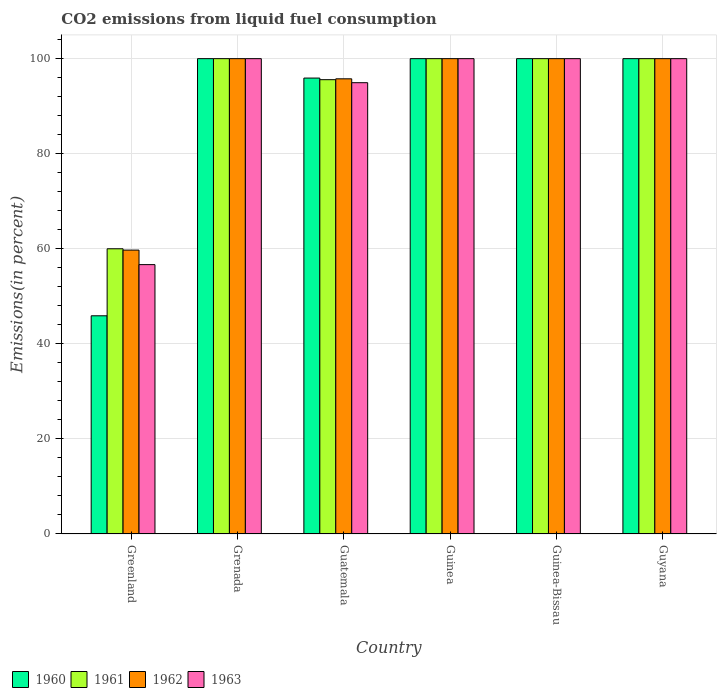Are the number of bars on each tick of the X-axis equal?
Ensure brevity in your answer.  Yes. What is the label of the 1st group of bars from the left?
Ensure brevity in your answer.  Greenland. In how many cases, is the number of bars for a given country not equal to the number of legend labels?
Offer a terse response. 0. What is the total CO2 emitted in 1961 in Greenland?
Offer a terse response. 60. Across all countries, what is the maximum total CO2 emitted in 1963?
Offer a very short reply. 100. Across all countries, what is the minimum total CO2 emitted in 1963?
Your answer should be very brief. 56.67. In which country was the total CO2 emitted in 1961 maximum?
Your answer should be very brief. Grenada. In which country was the total CO2 emitted in 1960 minimum?
Your answer should be very brief. Greenland. What is the total total CO2 emitted in 1962 in the graph?
Provide a succinct answer. 555.48. What is the difference between the total CO2 emitted in 1960 in Guinea-Bissau and that in Guyana?
Offer a very short reply. 0. What is the difference between the total CO2 emitted in 1961 in Guyana and the total CO2 emitted in 1963 in Greenland?
Provide a short and direct response. 43.33. What is the average total CO2 emitted in 1962 per country?
Give a very brief answer. 92.58. What is the difference between the total CO2 emitted of/in 1960 and total CO2 emitted of/in 1962 in Guatemala?
Ensure brevity in your answer.  0.16. In how many countries, is the total CO2 emitted in 1960 greater than 92 %?
Your answer should be compact. 5. What is the ratio of the total CO2 emitted in 1963 in Grenada to that in Guinea-Bissau?
Offer a terse response. 1. Is the difference between the total CO2 emitted in 1960 in Grenada and Guyana greater than the difference between the total CO2 emitted in 1962 in Grenada and Guyana?
Give a very brief answer. No. What is the difference between the highest and the lowest total CO2 emitted in 1961?
Give a very brief answer. 40. In how many countries, is the total CO2 emitted in 1961 greater than the average total CO2 emitted in 1961 taken over all countries?
Offer a terse response. 5. Is it the case that in every country, the sum of the total CO2 emitted in 1962 and total CO2 emitted in 1960 is greater than the sum of total CO2 emitted in 1961 and total CO2 emitted in 1963?
Offer a terse response. No. Is it the case that in every country, the sum of the total CO2 emitted in 1962 and total CO2 emitted in 1960 is greater than the total CO2 emitted in 1961?
Keep it short and to the point. Yes. How many bars are there?
Keep it short and to the point. 24. Are all the bars in the graph horizontal?
Provide a succinct answer. No. How many countries are there in the graph?
Make the answer very short. 6. Does the graph contain any zero values?
Keep it short and to the point. No. Does the graph contain grids?
Give a very brief answer. Yes. How many legend labels are there?
Keep it short and to the point. 4. What is the title of the graph?
Your response must be concise. CO2 emissions from liquid fuel consumption. Does "1989" appear as one of the legend labels in the graph?
Keep it short and to the point. No. What is the label or title of the X-axis?
Provide a short and direct response. Country. What is the label or title of the Y-axis?
Your response must be concise. Emissions(in percent). What is the Emissions(in percent) of 1960 in Greenland?
Provide a short and direct response. 45.9. What is the Emissions(in percent) of 1962 in Greenland?
Your answer should be very brief. 59.72. What is the Emissions(in percent) of 1963 in Greenland?
Offer a very short reply. 56.67. What is the Emissions(in percent) of 1960 in Grenada?
Your answer should be compact. 100. What is the Emissions(in percent) in 1963 in Grenada?
Keep it short and to the point. 100. What is the Emissions(in percent) of 1960 in Guatemala?
Give a very brief answer. 95.91. What is the Emissions(in percent) of 1961 in Guatemala?
Your answer should be very brief. 95.57. What is the Emissions(in percent) of 1962 in Guatemala?
Give a very brief answer. 95.76. What is the Emissions(in percent) of 1963 in Guatemala?
Make the answer very short. 94.94. What is the Emissions(in percent) of 1961 in Guinea?
Keep it short and to the point. 100. What is the Emissions(in percent) in 1962 in Guinea?
Your response must be concise. 100. What is the Emissions(in percent) in 1960 in Guinea-Bissau?
Ensure brevity in your answer.  100. What is the Emissions(in percent) in 1962 in Guinea-Bissau?
Your answer should be compact. 100. What is the Emissions(in percent) in 1963 in Guinea-Bissau?
Make the answer very short. 100. What is the Emissions(in percent) of 1960 in Guyana?
Provide a succinct answer. 100. Across all countries, what is the maximum Emissions(in percent) in 1960?
Make the answer very short. 100. Across all countries, what is the maximum Emissions(in percent) of 1961?
Give a very brief answer. 100. Across all countries, what is the minimum Emissions(in percent) in 1960?
Offer a terse response. 45.9. Across all countries, what is the minimum Emissions(in percent) in 1961?
Your answer should be very brief. 60. Across all countries, what is the minimum Emissions(in percent) in 1962?
Make the answer very short. 59.72. Across all countries, what is the minimum Emissions(in percent) in 1963?
Your response must be concise. 56.67. What is the total Emissions(in percent) in 1960 in the graph?
Keep it short and to the point. 541.81. What is the total Emissions(in percent) in 1961 in the graph?
Provide a succinct answer. 555.57. What is the total Emissions(in percent) in 1962 in the graph?
Your answer should be very brief. 555.48. What is the total Emissions(in percent) of 1963 in the graph?
Keep it short and to the point. 551.61. What is the difference between the Emissions(in percent) of 1960 in Greenland and that in Grenada?
Provide a succinct answer. -54.1. What is the difference between the Emissions(in percent) of 1961 in Greenland and that in Grenada?
Ensure brevity in your answer.  -40. What is the difference between the Emissions(in percent) of 1962 in Greenland and that in Grenada?
Provide a succinct answer. -40.28. What is the difference between the Emissions(in percent) in 1963 in Greenland and that in Grenada?
Offer a very short reply. -43.33. What is the difference between the Emissions(in percent) of 1960 in Greenland and that in Guatemala?
Keep it short and to the point. -50.01. What is the difference between the Emissions(in percent) in 1961 in Greenland and that in Guatemala?
Your answer should be compact. -35.57. What is the difference between the Emissions(in percent) of 1962 in Greenland and that in Guatemala?
Offer a very short reply. -36.03. What is the difference between the Emissions(in percent) in 1963 in Greenland and that in Guatemala?
Ensure brevity in your answer.  -38.27. What is the difference between the Emissions(in percent) of 1960 in Greenland and that in Guinea?
Your answer should be compact. -54.1. What is the difference between the Emissions(in percent) in 1962 in Greenland and that in Guinea?
Offer a very short reply. -40.28. What is the difference between the Emissions(in percent) in 1963 in Greenland and that in Guinea?
Ensure brevity in your answer.  -43.33. What is the difference between the Emissions(in percent) of 1960 in Greenland and that in Guinea-Bissau?
Your answer should be very brief. -54.1. What is the difference between the Emissions(in percent) in 1961 in Greenland and that in Guinea-Bissau?
Your answer should be compact. -40. What is the difference between the Emissions(in percent) of 1962 in Greenland and that in Guinea-Bissau?
Provide a short and direct response. -40.28. What is the difference between the Emissions(in percent) in 1963 in Greenland and that in Guinea-Bissau?
Keep it short and to the point. -43.33. What is the difference between the Emissions(in percent) in 1960 in Greenland and that in Guyana?
Your answer should be compact. -54.1. What is the difference between the Emissions(in percent) in 1961 in Greenland and that in Guyana?
Keep it short and to the point. -40. What is the difference between the Emissions(in percent) in 1962 in Greenland and that in Guyana?
Give a very brief answer. -40.28. What is the difference between the Emissions(in percent) of 1963 in Greenland and that in Guyana?
Offer a terse response. -43.33. What is the difference between the Emissions(in percent) in 1960 in Grenada and that in Guatemala?
Offer a very short reply. 4.09. What is the difference between the Emissions(in percent) of 1961 in Grenada and that in Guatemala?
Provide a succinct answer. 4.43. What is the difference between the Emissions(in percent) of 1962 in Grenada and that in Guatemala?
Provide a succinct answer. 4.24. What is the difference between the Emissions(in percent) in 1963 in Grenada and that in Guatemala?
Your answer should be very brief. 5.06. What is the difference between the Emissions(in percent) of 1960 in Grenada and that in Guinea?
Give a very brief answer. 0. What is the difference between the Emissions(in percent) in 1963 in Grenada and that in Guinea-Bissau?
Keep it short and to the point. 0. What is the difference between the Emissions(in percent) in 1962 in Grenada and that in Guyana?
Keep it short and to the point. 0. What is the difference between the Emissions(in percent) in 1960 in Guatemala and that in Guinea?
Your response must be concise. -4.09. What is the difference between the Emissions(in percent) in 1961 in Guatemala and that in Guinea?
Offer a very short reply. -4.43. What is the difference between the Emissions(in percent) in 1962 in Guatemala and that in Guinea?
Keep it short and to the point. -4.24. What is the difference between the Emissions(in percent) in 1963 in Guatemala and that in Guinea?
Keep it short and to the point. -5.06. What is the difference between the Emissions(in percent) of 1960 in Guatemala and that in Guinea-Bissau?
Offer a very short reply. -4.09. What is the difference between the Emissions(in percent) of 1961 in Guatemala and that in Guinea-Bissau?
Offer a very short reply. -4.43. What is the difference between the Emissions(in percent) of 1962 in Guatemala and that in Guinea-Bissau?
Ensure brevity in your answer.  -4.24. What is the difference between the Emissions(in percent) in 1963 in Guatemala and that in Guinea-Bissau?
Give a very brief answer. -5.06. What is the difference between the Emissions(in percent) in 1960 in Guatemala and that in Guyana?
Ensure brevity in your answer.  -4.09. What is the difference between the Emissions(in percent) of 1961 in Guatemala and that in Guyana?
Provide a succinct answer. -4.43. What is the difference between the Emissions(in percent) of 1962 in Guatemala and that in Guyana?
Keep it short and to the point. -4.24. What is the difference between the Emissions(in percent) in 1963 in Guatemala and that in Guyana?
Offer a very short reply. -5.06. What is the difference between the Emissions(in percent) of 1960 in Guinea and that in Guinea-Bissau?
Offer a very short reply. 0. What is the difference between the Emissions(in percent) of 1961 in Guinea and that in Guinea-Bissau?
Offer a very short reply. 0. What is the difference between the Emissions(in percent) in 1962 in Guinea and that in Guinea-Bissau?
Provide a succinct answer. 0. What is the difference between the Emissions(in percent) in 1960 in Guinea and that in Guyana?
Your answer should be very brief. 0. What is the difference between the Emissions(in percent) in 1961 in Guinea and that in Guyana?
Provide a succinct answer. 0. What is the difference between the Emissions(in percent) in 1962 in Guinea and that in Guyana?
Provide a succinct answer. 0. What is the difference between the Emissions(in percent) in 1963 in Guinea and that in Guyana?
Your answer should be very brief. 0. What is the difference between the Emissions(in percent) of 1960 in Guinea-Bissau and that in Guyana?
Your answer should be compact. 0. What is the difference between the Emissions(in percent) in 1961 in Guinea-Bissau and that in Guyana?
Your response must be concise. 0. What is the difference between the Emissions(in percent) of 1960 in Greenland and the Emissions(in percent) of 1961 in Grenada?
Your answer should be very brief. -54.1. What is the difference between the Emissions(in percent) of 1960 in Greenland and the Emissions(in percent) of 1962 in Grenada?
Provide a succinct answer. -54.1. What is the difference between the Emissions(in percent) in 1960 in Greenland and the Emissions(in percent) in 1963 in Grenada?
Make the answer very short. -54.1. What is the difference between the Emissions(in percent) in 1962 in Greenland and the Emissions(in percent) in 1963 in Grenada?
Your response must be concise. -40.28. What is the difference between the Emissions(in percent) in 1960 in Greenland and the Emissions(in percent) in 1961 in Guatemala?
Your answer should be very brief. -49.67. What is the difference between the Emissions(in percent) of 1960 in Greenland and the Emissions(in percent) of 1962 in Guatemala?
Your response must be concise. -49.85. What is the difference between the Emissions(in percent) in 1960 in Greenland and the Emissions(in percent) in 1963 in Guatemala?
Make the answer very short. -49.04. What is the difference between the Emissions(in percent) of 1961 in Greenland and the Emissions(in percent) of 1962 in Guatemala?
Provide a short and direct response. -35.76. What is the difference between the Emissions(in percent) of 1961 in Greenland and the Emissions(in percent) of 1963 in Guatemala?
Keep it short and to the point. -34.94. What is the difference between the Emissions(in percent) of 1962 in Greenland and the Emissions(in percent) of 1963 in Guatemala?
Provide a succinct answer. -35.22. What is the difference between the Emissions(in percent) of 1960 in Greenland and the Emissions(in percent) of 1961 in Guinea?
Offer a very short reply. -54.1. What is the difference between the Emissions(in percent) in 1960 in Greenland and the Emissions(in percent) in 1962 in Guinea?
Provide a short and direct response. -54.1. What is the difference between the Emissions(in percent) of 1960 in Greenland and the Emissions(in percent) of 1963 in Guinea?
Provide a succinct answer. -54.1. What is the difference between the Emissions(in percent) in 1961 in Greenland and the Emissions(in percent) in 1963 in Guinea?
Your answer should be compact. -40. What is the difference between the Emissions(in percent) in 1962 in Greenland and the Emissions(in percent) in 1963 in Guinea?
Provide a short and direct response. -40.28. What is the difference between the Emissions(in percent) in 1960 in Greenland and the Emissions(in percent) in 1961 in Guinea-Bissau?
Offer a very short reply. -54.1. What is the difference between the Emissions(in percent) of 1960 in Greenland and the Emissions(in percent) of 1962 in Guinea-Bissau?
Keep it short and to the point. -54.1. What is the difference between the Emissions(in percent) of 1960 in Greenland and the Emissions(in percent) of 1963 in Guinea-Bissau?
Make the answer very short. -54.1. What is the difference between the Emissions(in percent) of 1962 in Greenland and the Emissions(in percent) of 1963 in Guinea-Bissau?
Your answer should be very brief. -40.28. What is the difference between the Emissions(in percent) of 1960 in Greenland and the Emissions(in percent) of 1961 in Guyana?
Ensure brevity in your answer.  -54.1. What is the difference between the Emissions(in percent) in 1960 in Greenland and the Emissions(in percent) in 1962 in Guyana?
Keep it short and to the point. -54.1. What is the difference between the Emissions(in percent) in 1960 in Greenland and the Emissions(in percent) in 1963 in Guyana?
Give a very brief answer. -54.1. What is the difference between the Emissions(in percent) of 1961 in Greenland and the Emissions(in percent) of 1962 in Guyana?
Give a very brief answer. -40. What is the difference between the Emissions(in percent) in 1962 in Greenland and the Emissions(in percent) in 1963 in Guyana?
Your answer should be compact. -40.28. What is the difference between the Emissions(in percent) in 1960 in Grenada and the Emissions(in percent) in 1961 in Guatemala?
Offer a terse response. 4.43. What is the difference between the Emissions(in percent) in 1960 in Grenada and the Emissions(in percent) in 1962 in Guatemala?
Make the answer very short. 4.24. What is the difference between the Emissions(in percent) of 1960 in Grenada and the Emissions(in percent) of 1963 in Guatemala?
Provide a succinct answer. 5.06. What is the difference between the Emissions(in percent) of 1961 in Grenada and the Emissions(in percent) of 1962 in Guatemala?
Provide a succinct answer. 4.24. What is the difference between the Emissions(in percent) of 1961 in Grenada and the Emissions(in percent) of 1963 in Guatemala?
Offer a very short reply. 5.06. What is the difference between the Emissions(in percent) of 1962 in Grenada and the Emissions(in percent) of 1963 in Guatemala?
Keep it short and to the point. 5.06. What is the difference between the Emissions(in percent) in 1960 in Grenada and the Emissions(in percent) in 1961 in Guinea?
Your answer should be very brief. 0. What is the difference between the Emissions(in percent) of 1960 in Grenada and the Emissions(in percent) of 1963 in Guinea?
Offer a terse response. 0. What is the difference between the Emissions(in percent) of 1960 in Grenada and the Emissions(in percent) of 1961 in Guinea-Bissau?
Make the answer very short. 0. What is the difference between the Emissions(in percent) in 1960 in Grenada and the Emissions(in percent) in 1962 in Guinea-Bissau?
Offer a very short reply. 0. What is the difference between the Emissions(in percent) of 1960 in Grenada and the Emissions(in percent) of 1963 in Guinea-Bissau?
Provide a succinct answer. 0. What is the difference between the Emissions(in percent) in 1961 in Grenada and the Emissions(in percent) in 1962 in Guinea-Bissau?
Ensure brevity in your answer.  0. What is the difference between the Emissions(in percent) in 1961 in Grenada and the Emissions(in percent) in 1963 in Guinea-Bissau?
Your answer should be compact. 0. What is the difference between the Emissions(in percent) in 1960 in Grenada and the Emissions(in percent) in 1961 in Guyana?
Your answer should be very brief. 0. What is the difference between the Emissions(in percent) in 1961 in Grenada and the Emissions(in percent) in 1963 in Guyana?
Your answer should be very brief. 0. What is the difference between the Emissions(in percent) in 1962 in Grenada and the Emissions(in percent) in 1963 in Guyana?
Ensure brevity in your answer.  0. What is the difference between the Emissions(in percent) of 1960 in Guatemala and the Emissions(in percent) of 1961 in Guinea?
Keep it short and to the point. -4.09. What is the difference between the Emissions(in percent) of 1960 in Guatemala and the Emissions(in percent) of 1962 in Guinea?
Offer a very short reply. -4.09. What is the difference between the Emissions(in percent) in 1960 in Guatemala and the Emissions(in percent) in 1963 in Guinea?
Your answer should be very brief. -4.09. What is the difference between the Emissions(in percent) in 1961 in Guatemala and the Emissions(in percent) in 1962 in Guinea?
Provide a short and direct response. -4.43. What is the difference between the Emissions(in percent) of 1961 in Guatemala and the Emissions(in percent) of 1963 in Guinea?
Give a very brief answer. -4.43. What is the difference between the Emissions(in percent) of 1962 in Guatemala and the Emissions(in percent) of 1963 in Guinea?
Offer a terse response. -4.24. What is the difference between the Emissions(in percent) of 1960 in Guatemala and the Emissions(in percent) of 1961 in Guinea-Bissau?
Keep it short and to the point. -4.09. What is the difference between the Emissions(in percent) in 1960 in Guatemala and the Emissions(in percent) in 1962 in Guinea-Bissau?
Keep it short and to the point. -4.09. What is the difference between the Emissions(in percent) of 1960 in Guatemala and the Emissions(in percent) of 1963 in Guinea-Bissau?
Ensure brevity in your answer.  -4.09. What is the difference between the Emissions(in percent) of 1961 in Guatemala and the Emissions(in percent) of 1962 in Guinea-Bissau?
Your response must be concise. -4.43. What is the difference between the Emissions(in percent) of 1961 in Guatemala and the Emissions(in percent) of 1963 in Guinea-Bissau?
Offer a very short reply. -4.43. What is the difference between the Emissions(in percent) of 1962 in Guatemala and the Emissions(in percent) of 1963 in Guinea-Bissau?
Ensure brevity in your answer.  -4.24. What is the difference between the Emissions(in percent) of 1960 in Guatemala and the Emissions(in percent) of 1961 in Guyana?
Offer a terse response. -4.09. What is the difference between the Emissions(in percent) in 1960 in Guatemala and the Emissions(in percent) in 1962 in Guyana?
Your answer should be very brief. -4.09. What is the difference between the Emissions(in percent) of 1960 in Guatemala and the Emissions(in percent) of 1963 in Guyana?
Make the answer very short. -4.09. What is the difference between the Emissions(in percent) of 1961 in Guatemala and the Emissions(in percent) of 1962 in Guyana?
Provide a short and direct response. -4.43. What is the difference between the Emissions(in percent) of 1961 in Guatemala and the Emissions(in percent) of 1963 in Guyana?
Provide a short and direct response. -4.43. What is the difference between the Emissions(in percent) in 1962 in Guatemala and the Emissions(in percent) in 1963 in Guyana?
Your response must be concise. -4.24. What is the difference between the Emissions(in percent) in 1960 in Guinea and the Emissions(in percent) in 1961 in Guinea-Bissau?
Provide a short and direct response. 0. What is the difference between the Emissions(in percent) in 1960 in Guinea and the Emissions(in percent) in 1963 in Guinea-Bissau?
Provide a short and direct response. 0. What is the difference between the Emissions(in percent) in 1961 in Guinea and the Emissions(in percent) in 1963 in Guinea-Bissau?
Give a very brief answer. 0. What is the difference between the Emissions(in percent) of 1962 in Guinea and the Emissions(in percent) of 1963 in Guinea-Bissau?
Keep it short and to the point. 0. What is the difference between the Emissions(in percent) of 1960 in Guinea and the Emissions(in percent) of 1962 in Guyana?
Provide a short and direct response. 0. What is the difference between the Emissions(in percent) in 1960 in Guinea and the Emissions(in percent) in 1963 in Guyana?
Ensure brevity in your answer.  0. What is the difference between the Emissions(in percent) of 1961 in Guinea and the Emissions(in percent) of 1962 in Guyana?
Offer a very short reply. 0. What is the difference between the Emissions(in percent) in 1962 in Guinea and the Emissions(in percent) in 1963 in Guyana?
Offer a very short reply. 0. What is the difference between the Emissions(in percent) of 1960 in Guinea-Bissau and the Emissions(in percent) of 1962 in Guyana?
Ensure brevity in your answer.  0. What is the difference between the Emissions(in percent) in 1960 in Guinea-Bissau and the Emissions(in percent) in 1963 in Guyana?
Make the answer very short. 0. What is the average Emissions(in percent) of 1960 per country?
Ensure brevity in your answer.  90.3. What is the average Emissions(in percent) in 1961 per country?
Your answer should be very brief. 92.6. What is the average Emissions(in percent) in 1962 per country?
Offer a terse response. 92.58. What is the average Emissions(in percent) of 1963 per country?
Offer a terse response. 91.93. What is the difference between the Emissions(in percent) in 1960 and Emissions(in percent) in 1961 in Greenland?
Make the answer very short. -14.1. What is the difference between the Emissions(in percent) of 1960 and Emissions(in percent) of 1962 in Greenland?
Offer a terse response. -13.82. What is the difference between the Emissions(in percent) of 1960 and Emissions(in percent) of 1963 in Greenland?
Provide a succinct answer. -10.77. What is the difference between the Emissions(in percent) of 1961 and Emissions(in percent) of 1962 in Greenland?
Ensure brevity in your answer.  0.28. What is the difference between the Emissions(in percent) of 1962 and Emissions(in percent) of 1963 in Greenland?
Provide a succinct answer. 3.06. What is the difference between the Emissions(in percent) of 1960 and Emissions(in percent) of 1961 in Grenada?
Ensure brevity in your answer.  0. What is the difference between the Emissions(in percent) of 1960 and Emissions(in percent) of 1963 in Grenada?
Give a very brief answer. 0. What is the difference between the Emissions(in percent) of 1961 and Emissions(in percent) of 1962 in Grenada?
Offer a very short reply. 0. What is the difference between the Emissions(in percent) of 1961 and Emissions(in percent) of 1963 in Grenada?
Offer a terse response. 0. What is the difference between the Emissions(in percent) in 1960 and Emissions(in percent) in 1961 in Guatemala?
Give a very brief answer. 0.34. What is the difference between the Emissions(in percent) in 1960 and Emissions(in percent) in 1962 in Guatemala?
Provide a succinct answer. 0.16. What is the difference between the Emissions(in percent) of 1961 and Emissions(in percent) of 1962 in Guatemala?
Keep it short and to the point. -0.18. What is the difference between the Emissions(in percent) in 1961 and Emissions(in percent) in 1963 in Guatemala?
Keep it short and to the point. 0.63. What is the difference between the Emissions(in percent) in 1962 and Emissions(in percent) in 1963 in Guatemala?
Give a very brief answer. 0.82. What is the difference between the Emissions(in percent) in 1961 and Emissions(in percent) in 1962 in Guinea?
Keep it short and to the point. 0. What is the difference between the Emissions(in percent) in 1961 and Emissions(in percent) in 1963 in Guinea?
Ensure brevity in your answer.  0. What is the difference between the Emissions(in percent) in 1961 and Emissions(in percent) in 1963 in Guinea-Bissau?
Your answer should be compact. 0. What is the difference between the Emissions(in percent) in 1962 and Emissions(in percent) in 1963 in Guinea-Bissau?
Offer a terse response. 0. What is the difference between the Emissions(in percent) of 1960 and Emissions(in percent) of 1962 in Guyana?
Keep it short and to the point. 0. What is the difference between the Emissions(in percent) of 1960 and Emissions(in percent) of 1963 in Guyana?
Provide a short and direct response. 0. What is the difference between the Emissions(in percent) in 1961 and Emissions(in percent) in 1962 in Guyana?
Give a very brief answer. 0. What is the difference between the Emissions(in percent) in 1961 and Emissions(in percent) in 1963 in Guyana?
Provide a short and direct response. 0. What is the ratio of the Emissions(in percent) of 1960 in Greenland to that in Grenada?
Give a very brief answer. 0.46. What is the ratio of the Emissions(in percent) of 1962 in Greenland to that in Grenada?
Your answer should be very brief. 0.6. What is the ratio of the Emissions(in percent) in 1963 in Greenland to that in Grenada?
Your response must be concise. 0.57. What is the ratio of the Emissions(in percent) in 1960 in Greenland to that in Guatemala?
Ensure brevity in your answer.  0.48. What is the ratio of the Emissions(in percent) in 1961 in Greenland to that in Guatemala?
Give a very brief answer. 0.63. What is the ratio of the Emissions(in percent) of 1962 in Greenland to that in Guatemala?
Provide a succinct answer. 0.62. What is the ratio of the Emissions(in percent) of 1963 in Greenland to that in Guatemala?
Ensure brevity in your answer.  0.6. What is the ratio of the Emissions(in percent) of 1960 in Greenland to that in Guinea?
Provide a short and direct response. 0.46. What is the ratio of the Emissions(in percent) of 1961 in Greenland to that in Guinea?
Ensure brevity in your answer.  0.6. What is the ratio of the Emissions(in percent) in 1962 in Greenland to that in Guinea?
Your answer should be very brief. 0.6. What is the ratio of the Emissions(in percent) of 1963 in Greenland to that in Guinea?
Offer a terse response. 0.57. What is the ratio of the Emissions(in percent) of 1960 in Greenland to that in Guinea-Bissau?
Provide a succinct answer. 0.46. What is the ratio of the Emissions(in percent) of 1961 in Greenland to that in Guinea-Bissau?
Your response must be concise. 0.6. What is the ratio of the Emissions(in percent) in 1962 in Greenland to that in Guinea-Bissau?
Give a very brief answer. 0.6. What is the ratio of the Emissions(in percent) in 1963 in Greenland to that in Guinea-Bissau?
Your answer should be compact. 0.57. What is the ratio of the Emissions(in percent) in 1960 in Greenland to that in Guyana?
Give a very brief answer. 0.46. What is the ratio of the Emissions(in percent) of 1962 in Greenland to that in Guyana?
Offer a terse response. 0.6. What is the ratio of the Emissions(in percent) of 1963 in Greenland to that in Guyana?
Keep it short and to the point. 0.57. What is the ratio of the Emissions(in percent) of 1960 in Grenada to that in Guatemala?
Offer a very short reply. 1.04. What is the ratio of the Emissions(in percent) of 1961 in Grenada to that in Guatemala?
Keep it short and to the point. 1.05. What is the ratio of the Emissions(in percent) in 1962 in Grenada to that in Guatemala?
Provide a succinct answer. 1.04. What is the ratio of the Emissions(in percent) of 1963 in Grenada to that in Guatemala?
Provide a succinct answer. 1.05. What is the ratio of the Emissions(in percent) of 1960 in Grenada to that in Guinea?
Offer a terse response. 1. What is the ratio of the Emissions(in percent) of 1961 in Grenada to that in Guinea?
Provide a short and direct response. 1. What is the ratio of the Emissions(in percent) of 1962 in Grenada to that in Guinea?
Offer a very short reply. 1. What is the ratio of the Emissions(in percent) in 1960 in Grenada to that in Guinea-Bissau?
Offer a very short reply. 1. What is the ratio of the Emissions(in percent) of 1962 in Grenada to that in Guinea-Bissau?
Offer a terse response. 1. What is the ratio of the Emissions(in percent) in 1960 in Grenada to that in Guyana?
Offer a very short reply. 1. What is the ratio of the Emissions(in percent) in 1962 in Grenada to that in Guyana?
Ensure brevity in your answer.  1. What is the ratio of the Emissions(in percent) of 1963 in Grenada to that in Guyana?
Offer a terse response. 1. What is the ratio of the Emissions(in percent) of 1960 in Guatemala to that in Guinea?
Your answer should be compact. 0.96. What is the ratio of the Emissions(in percent) in 1961 in Guatemala to that in Guinea?
Your response must be concise. 0.96. What is the ratio of the Emissions(in percent) of 1962 in Guatemala to that in Guinea?
Offer a terse response. 0.96. What is the ratio of the Emissions(in percent) in 1963 in Guatemala to that in Guinea?
Give a very brief answer. 0.95. What is the ratio of the Emissions(in percent) in 1960 in Guatemala to that in Guinea-Bissau?
Provide a succinct answer. 0.96. What is the ratio of the Emissions(in percent) of 1961 in Guatemala to that in Guinea-Bissau?
Make the answer very short. 0.96. What is the ratio of the Emissions(in percent) in 1962 in Guatemala to that in Guinea-Bissau?
Your answer should be very brief. 0.96. What is the ratio of the Emissions(in percent) of 1963 in Guatemala to that in Guinea-Bissau?
Offer a terse response. 0.95. What is the ratio of the Emissions(in percent) in 1960 in Guatemala to that in Guyana?
Keep it short and to the point. 0.96. What is the ratio of the Emissions(in percent) of 1961 in Guatemala to that in Guyana?
Provide a short and direct response. 0.96. What is the ratio of the Emissions(in percent) in 1962 in Guatemala to that in Guyana?
Offer a terse response. 0.96. What is the ratio of the Emissions(in percent) of 1963 in Guatemala to that in Guyana?
Provide a short and direct response. 0.95. What is the ratio of the Emissions(in percent) of 1961 in Guinea to that in Guinea-Bissau?
Your response must be concise. 1. What is the ratio of the Emissions(in percent) of 1962 in Guinea to that in Guinea-Bissau?
Keep it short and to the point. 1. What is the ratio of the Emissions(in percent) of 1963 in Guinea to that in Guyana?
Keep it short and to the point. 1. What is the ratio of the Emissions(in percent) in 1961 in Guinea-Bissau to that in Guyana?
Provide a short and direct response. 1. What is the ratio of the Emissions(in percent) of 1963 in Guinea-Bissau to that in Guyana?
Offer a very short reply. 1. What is the difference between the highest and the second highest Emissions(in percent) in 1961?
Give a very brief answer. 0. What is the difference between the highest and the lowest Emissions(in percent) of 1960?
Offer a terse response. 54.1. What is the difference between the highest and the lowest Emissions(in percent) of 1961?
Make the answer very short. 40. What is the difference between the highest and the lowest Emissions(in percent) of 1962?
Your answer should be very brief. 40.28. What is the difference between the highest and the lowest Emissions(in percent) of 1963?
Ensure brevity in your answer.  43.33. 